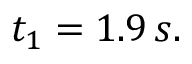Convert formula to latex. <formula><loc_0><loc_0><loc_500><loc_500>t _ { 1 } = 1 . 9 \, s .</formula> 